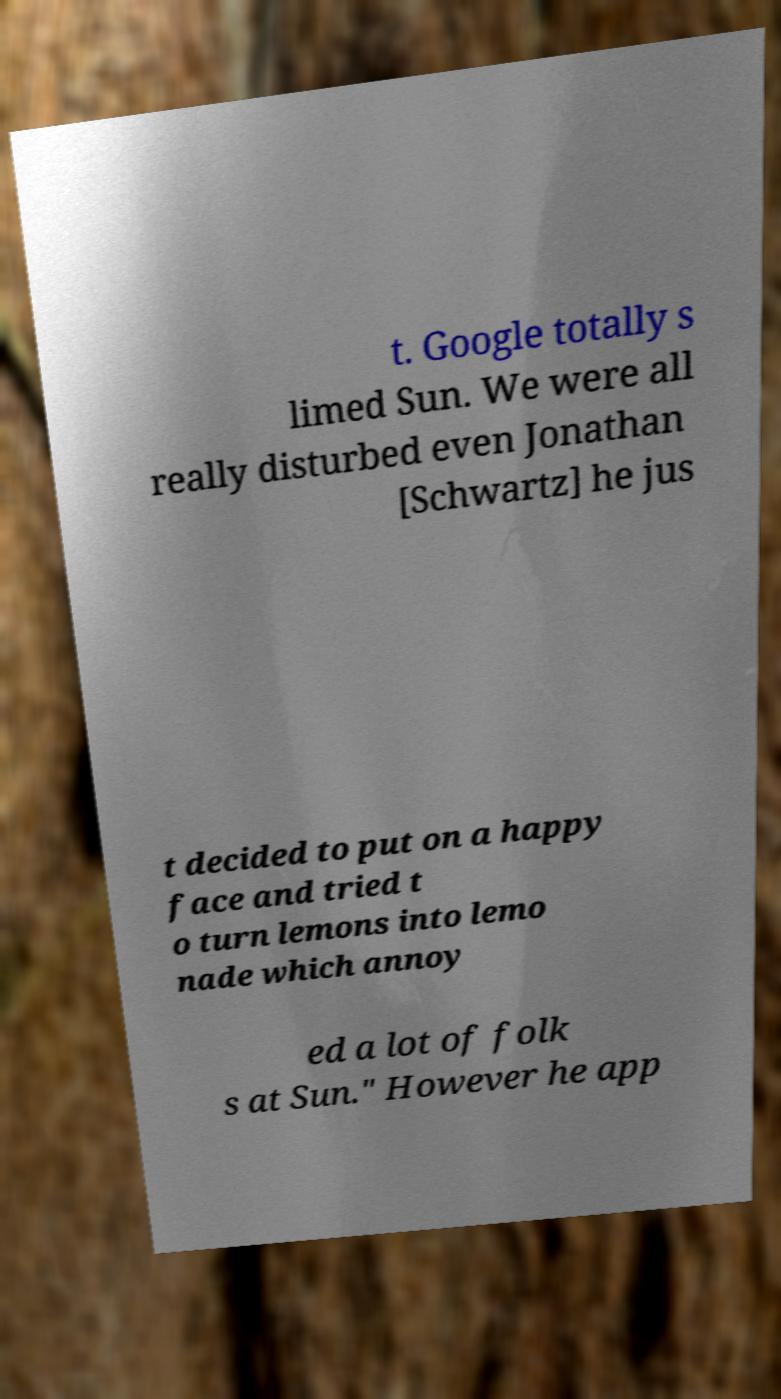What messages or text are displayed in this image? I need them in a readable, typed format. t. Google totally s limed Sun. We were all really disturbed even Jonathan [Schwartz] he jus t decided to put on a happy face and tried t o turn lemons into lemo nade which annoy ed a lot of folk s at Sun." However he app 